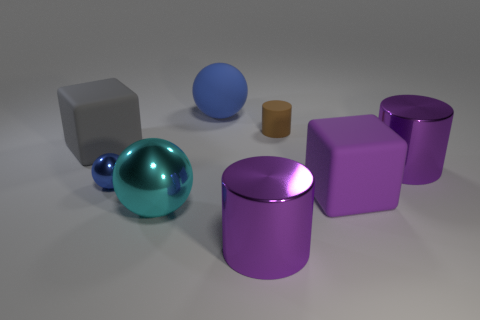The cyan thing that is the same size as the purple matte object is what shape? sphere 